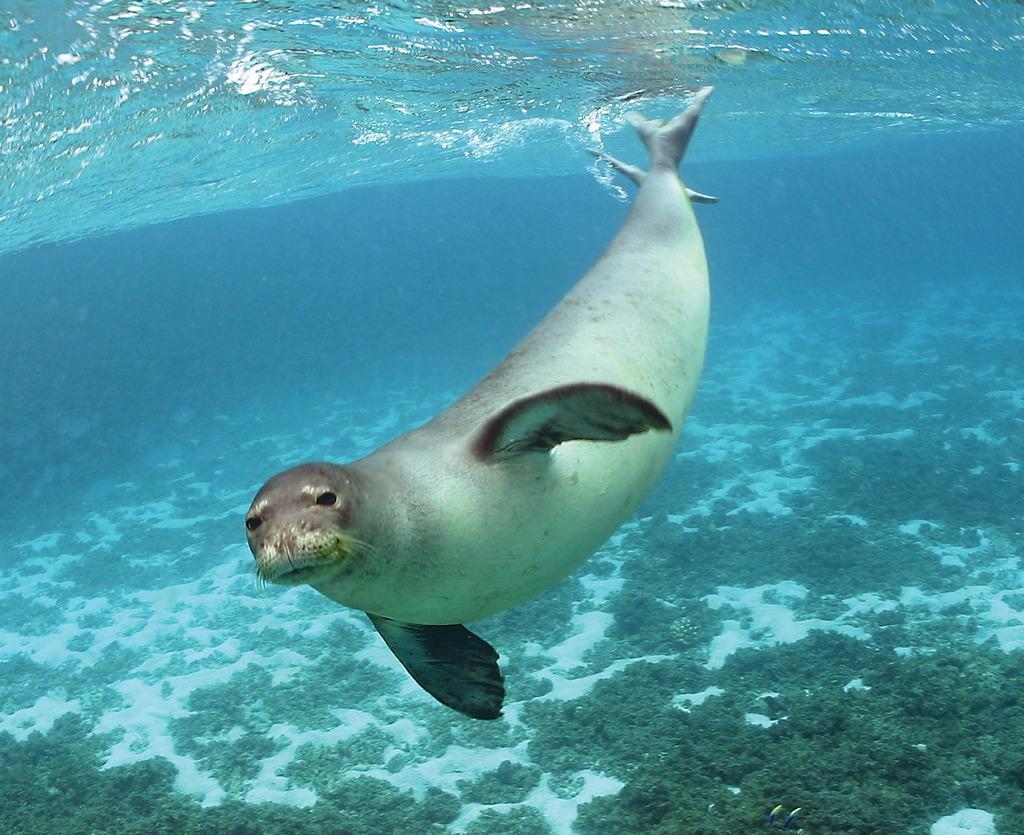Can you describe this image briefly? In the image we can see water, in the water we can see a seal. At the bottom of the image we can see some underwater plants. 